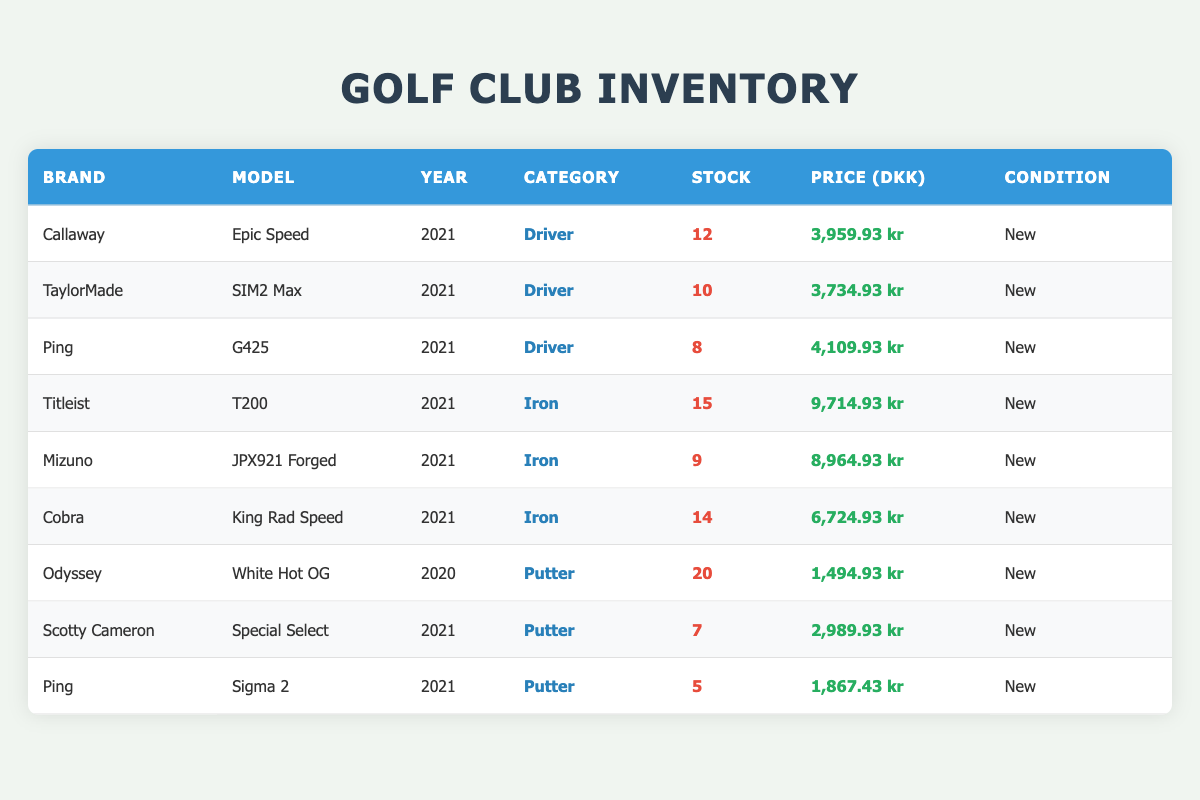What is the stock quantity of the Callaway Epic Speed driver? The stock quantity for each item is listed in the 'Stock' column. For the Callaway Epic Speed driver, the stock quantity is directly provided as 12.
Answer: 12 Which brand has the highest-priced iron in the inventory? The prices of irons can be found in the 'Price (DKK)' column for each brand. Upon checking the 2021 irons, Titleist T200 has the highest price at 9,714.93 kr.
Answer: Titleist Is the TaylorMade SIM2 Max a putter? By looking at the 'Category' column for the TaylorMade SIM2 Max, it is classified as a Driver, not a Putter, thus the answer is No.
Answer: No What is the total stock quantity of all putters listed? To find the total stock quantity of putters, we add the stock quantities of each putter: 20 (Odyssey) + 7 (Scotty Cameron) + 5 (Ping) = 32.
Answer: 32 How much cheaper is the Odyssey White Hot OG compared to the Ping G425 driver? First, look at the prices: Odyssey White Hot OG is 1,494.93 kr and the Ping G425 is 4,109.93 kr. Now subtract these amounts: 4,109.93 - 1,494.93 = 2,615 kr.
Answer: 2615 kr Which category has the most items in stock? Analyzing the stock quantities for all categories, Drivers (12 + 10 + 8 = 30), Irons (15 + 9 + 14 = 38), and Putters (20 + 7 + 5 = 32). The highest total is for Irons with 38.
Answer: Irons Are there any new golf clubs from 2020 in the inventory? Checking the 'Year' column, there is one item from 2020, which is the Odyssey White Hot OG putter, confirming that there is indeed a new item from 2020.
Answer: Yes What is the average price of all the 2021 drivers? Listing the prices of the 2021 drivers: Callaway Epic Speed: 3,959.93, TaylorMade SIM2 Max: 3,734.93, and Ping G425: 4,109.93. The sum is 3,959.93 + 3,734.93 + 4,109.93 = 11,804.79 kr, divided by the 3 drivers gives an average of 3,934.93 kr.
Answer: 3,934.93 kr Have any brands provided both drivers and putters in the inventory? By inspecting the table items, Ping appears both in the driver category (G425) and also as a putter (Sigma 2), confirming that they do have both types in the inventory.
Answer: Yes 